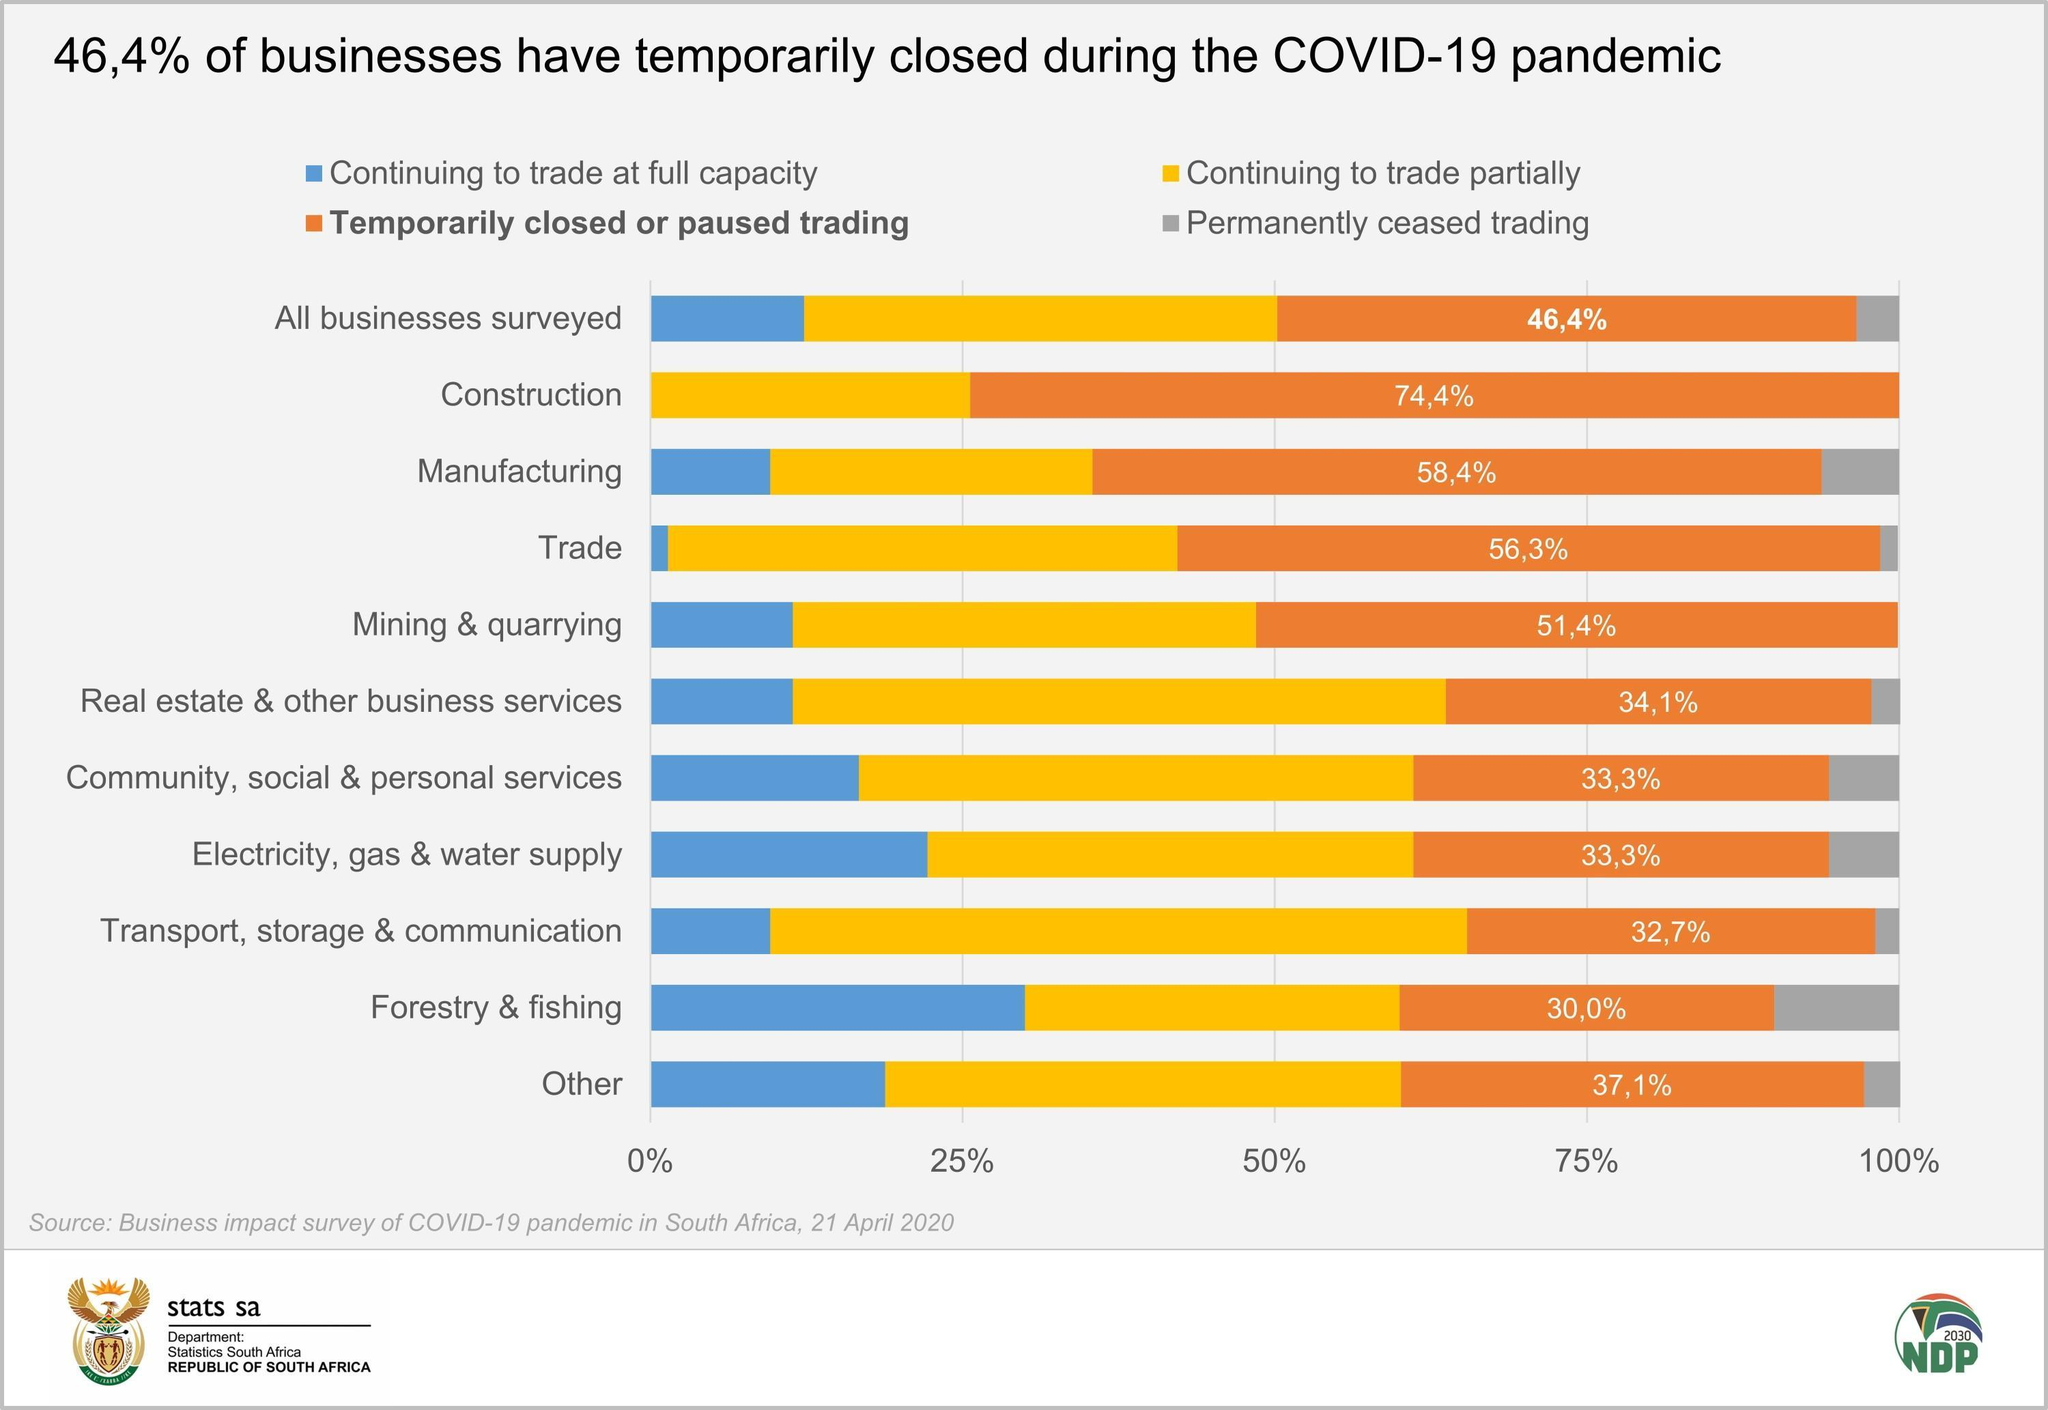what % of construction business continue to trade partially
Answer the question with a short phrase. 25.6 which business has been the least affected by temporary or permanent closure Transport, storage & communication which business have not had permanent ceased trading construction, mining & quarrying permanently ceased trading is being depicted in which colour, grey or blue grey Which business have not been able to continue to trade at fully capacity construction what % of mining and quarrying business continue to trade in full capacity or partially 48.6 continuing to trade at full capacity is shown in which colour, blue or yellow blue 